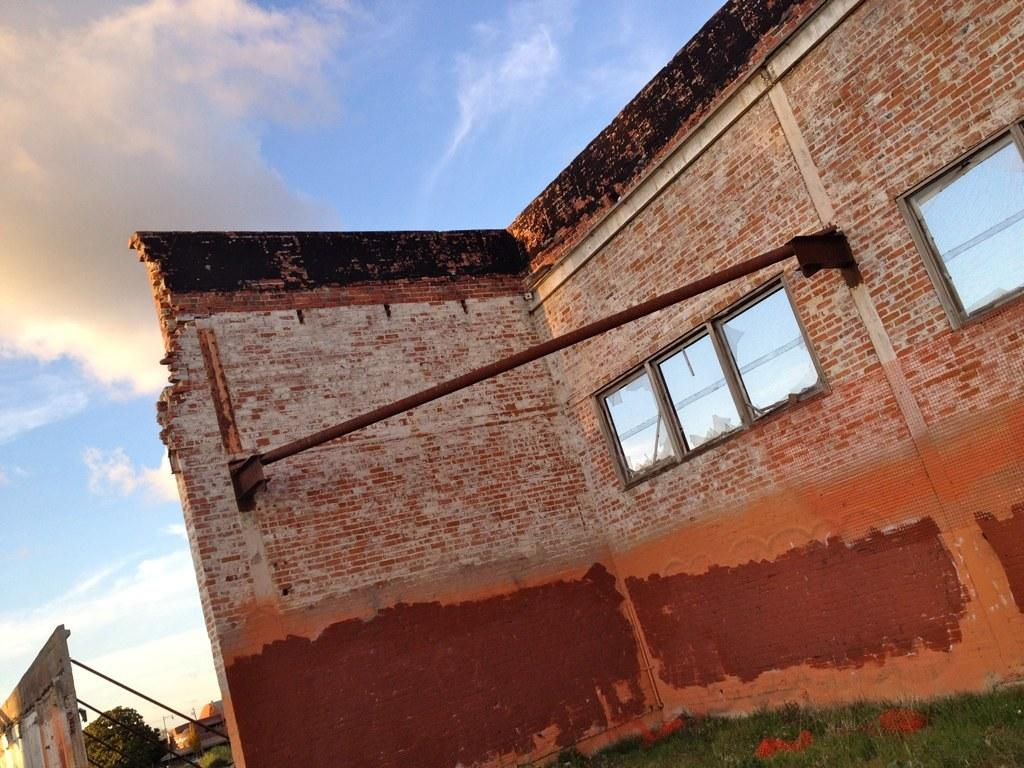What type of structures can be seen in the image? There are buildings in the image. What type of vegetation is present in the image? There are trees in the image. What type of ground cover is at the bottom of the image? There is grass at the bottom of the image. What is visible in the background of the image? The sky is visible in the background of the image. What type of jewel is hanging from the tree in the image? There is no jewel hanging from the tree in the image; only buildings, trees, grass, and the sky are present. 